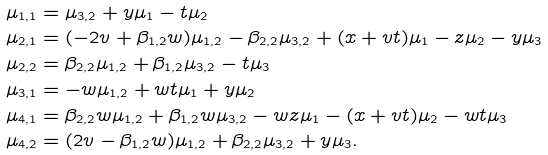Convert formula to latex. <formula><loc_0><loc_0><loc_500><loc_500>\mu _ { 1 , 1 } & = \mu _ { 3 , 2 } + y \mu _ { 1 } - t \mu _ { 2 } \\ \mu _ { 2 , 1 } & = ( - 2 v + \beta _ { 1 , 2 } w ) \mu _ { 1 , 2 } - \beta _ { 2 , 2 } \mu _ { 3 , 2 } + ( x + v t ) \mu _ { 1 } - z \mu _ { 2 } - y \mu _ { 3 } \\ \mu _ { 2 , 2 } & = \beta _ { 2 , 2 } \mu _ { 1 , 2 } + \beta _ { 1 , 2 } \mu _ { 3 , 2 } - t \mu _ { 3 } \\ \mu _ { 3 , 1 } & = - w \mu _ { 1 , 2 } + w t \mu _ { 1 } + y \mu _ { 2 } \\ \mu _ { 4 , 1 } & = \beta _ { 2 , 2 } w \mu _ { 1 , 2 } + \beta _ { 1 , 2 } w \mu _ { 3 , 2 } - w z \mu _ { 1 } - ( x + v t ) \mu _ { 2 } - w t \mu _ { 3 } \\ \mu _ { 4 , 2 } & = ( 2 v - \beta _ { 1 , 2 } w ) \mu _ { 1 , 2 } + \beta _ { 2 , 2 } \mu _ { 3 , 2 } + y \mu _ { 3 } .</formula> 